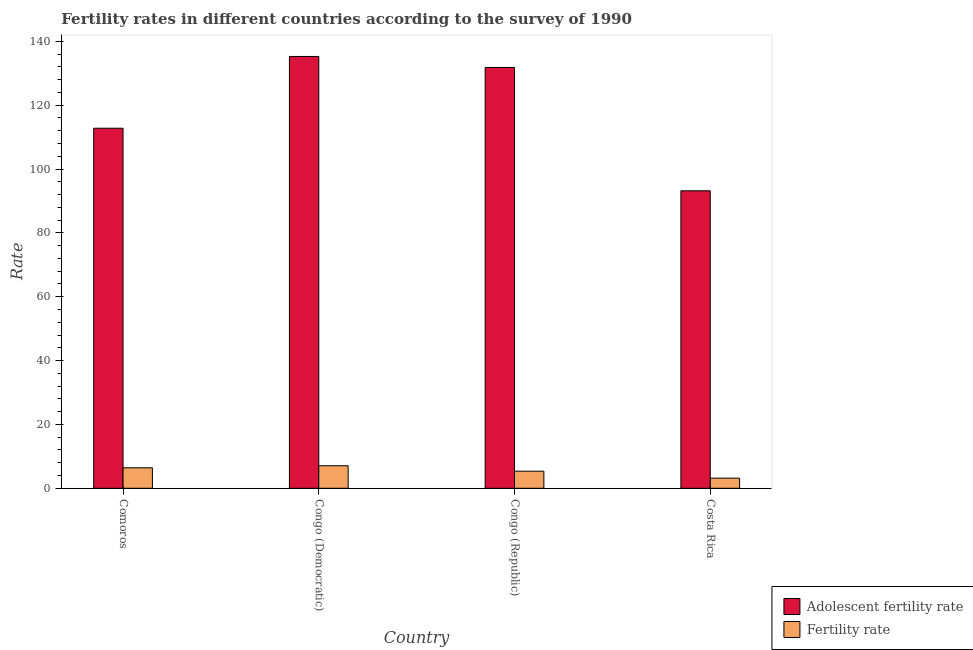Are the number of bars on each tick of the X-axis equal?
Offer a very short reply. Yes. What is the label of the 3rd group of bars from the left?
Provide a succinct answer. Congo (Republic). In how many cases, is the number of bars for a given country not equal to the number of legend labels?
Keep it short and to the point. 0. What is the adolescent fertility rate in Congo (Democratic)?
Give a very brief answer. 135.25. Across all countries, what is the maximum fertility rate?
Your answer should be very brief. 7.06. Across all countries, what is the minimum adolescent fertility rate?
Provide a succinct answer. 93.17. In which country was the fertility rate maximum?
Give a very brief answer. Congo (Democratic). What is the total fertility rate in the graph?
Ensure brevity in your answer.  21.99. What is the difference between the adolescent fertility rate in Congo (Democratic) and that in Congo (Republic)?
Keep it short and to the point. 3.44. What is the difference between the fertility rate in Congo (Republic) and the adolescent fertility rate in Comoros?
Provide a succinct answer. -107.42. What is the average adolescent fertility rate per country?
Your response must be concise. 118.25. What is the difference between the adolescent fertility rate and fertility rate in Comoros?
Keep it short and to the point. 106.36. What is the ratio of the adolescent fertility rate in Comoros to that in Congo (Democratic)?
Make the answer very short. 0.83. What is the difference between the highest and the second highest fertility rate?
Make the answer very short. 0.65. What is the difference between the highest and the lowest adolescent fertility rate?
Your answer should be very brief. 42.08. What does the 2nd bar from the left in Comoros represents?
Provide a succinct answer. Fertility rate. What does the 1st bar from the right in Comoros represents?
Make the answer very short. Fertility rate. How many bars are there?
Your answer should be compact. 8. How many countries are there in the graph?
Make the answer very short. 4. Are the values on the major ticks of Y-axis written in scientific E-notation?
Offer a very short reply. No. Does the graph contain any zero values?
Keep it short and to the point. No. Does the graph contain grids?
Offer a very short reply. No. Where does the legend appear in the graph?
Offer a very short reply. Bottom right. How are the legend labels stacked?
Provide a short and direct response. Vertical. What is the title of the graph?
Provide a succinct answer. Fertility rates in different countries according to the survey of 1990. Does "Official creditors" appear as one of the legend labels in the graph?
Provide a succinct answer. No. What is the label or title of the Y-axis?
Your answer should be compact. Rate. What is the Rate of Adolescent fertility rate in Comoros?
Provide a succinct answer. 112.77. What is the Rate of Fertility rate in Comoros?
Give a very brief answer. 6.41. What is the Rate in Adolescent fertility rate in Congo (Democratic)?
Give a very brief answer. 135.25. What is the Rate of Fertility rate in Congo (Democratic)?
Provide a short and direct response. 7.06. What is the Rate in Adolescent fertility rate in Congo (Republic)?
Keep it short and to the point. 131.81. What is the Rate of Fertility rate in Congo (Republic)?
Make the answer very short. 5.35. What is the Rate of Adolescent fertility rate in Costa Rica?
Ensure brevity in your answer.  93.17. What is the Rate of Fertility rate in Costa Rica?
Keep it short and to the point. 3.17. Across all countries, what is the maximum Rate of Adolescent fertility rate?
Offer a terse response. 135.25. Across all countries, what is the maximum Rate in Fertility rate?
Ensure brevity in your answer.  7.06. Across all countries, what is the minimum Rate of Adolescent fertility rate?
Keep it short and to the point. 93.17. Across all countries, what is the minimum Rate in Fertility rate?
Your answer should be very brief. 3.17. What is the total Rate in Adolescent fertility rate in the graph?
Offer a terse response. 473. What is the total Rate in Fertility rate in the graph?
Offer a terse response. 21.99. What is the difference between the Rate in Adolescent fertility rate in Comoros and that in Congo (Democratic)?
Provide a succinct answer. -22.48. What is the difference between the Rate in Fertility rate in Comoros and that in Congo (Democratic)?
Your answer should be compact. -0.65. What is the difference between the Rate in Adolescent fertility rate in Comoros and that in Congo (Republic)?
Ensure brevity in your answer.  -19.04. What is the difference between the Rate in Fertility rate in Comoros and that in Congo (Republic)?
Provide a succinct answer. 1.06. What is the difference between the Rate in Adolescent fertility rate in Comoros and that in Costa Rica?
Offer a terse response. 19.6. What is the difference between the Rate in Fertility rate in Comoros and that in Costa Rica?
Keep it short and to the point. 3.24. What is the difference between the Rate of Adolescent fertility rate in Congo (Democratic) and that in Congo (Republic)?
Provide a succinct answer. 3.44. What is the difference between the Rate of Fertility rate in Congo (Democratic) and that in Congo (Republic)?
Offer a very short reply. 1.71. What is the difference between the Rate of Adolescent fertility rate in Congo (Democratic) and that in Costa Rica?
Your response must be concise. 42.08. What is the difference between the Rate of Fertility rate in Congo (Democratic) and that in Costa Rica?
Keep it short and to the point. 3.89. What is the difference between the Rate of Adolescent fertility rate in Congo (Republic) and that in Costa Rica?
Offer a very short reply. 38.64. What is the difference between the Rate of Fertility rate in Congo (Republic) and that in Costa Rica?
Give a very brief answer. 2.18. What is the difference between the Rate of Adolescent fertility rate in Comoros and the Rate of Fertility rate in Congo (Democratic)?
Make the answer very short. 105.71. What is the difference between the Rate of Adolescent fertility rate in Comoros and the Rate of Fertility rate in Congo (Republic)?
Your response must be concise. 107.42. What is the difference between the Rate of Adolescent fertility rate in Comoros and the Rate of Fertility rate in Costa Rica?
Your response must be concise. 109.6. What is the difference between the Rate of Adolescent fertility rate in Congo (Democratic) and the Rate of Fertility rate in Congo (Republic)?
Give a very brief answer. 129.9. What is the difference between the Rate in Adolescent fertility rate in Congo (Democratic) and the Rate in Fertility rate in Costa Rica?
Make the answer very short. 132.08. What is the difference between the Rate in Adolescent fertility rate in Congo (Republic) and the Rate in Fertility rate in Costa Rica?
Keep it short and to the point. 128.64. What is the average Rate of Adolescent fertility rate per country?
Provide a short and direct response. 118.25. What is the average Rate in Fertility rate per country?
Give a very brief answer. 5.5. What is the difference between the Rate of Adolescent fertility rate and Rate of Fertility rate in Comoros?
Provide a short and direct response. 106.36. What is the difference between the Rate of Adolescent fertility rate and Rate of Fertility rate in Congo (Democratic)?
Your answer should be compact. 128.19. What is the difference between the Rate of Adolescent fertility rate and Rate of Fertility rate in Congo (Republic)?
Keep it short and to the point. 126.46. What is the difference between the Rate of Adolescent fertility rate and Rate of Fertility rate in Costa Rica?
Offer a terse response. 90. What is the ratio of the Rate of Adolescent fertility rate in Comoros to that in Congo (Democratic)?
Your answer should be very brief. 0.83. What is the ratio of the Rate of Fertility rate in Comoros to that in Congo (Democratic)?
Your response must be concise. 0.91. What is the ratio of the Rate in Adolescent fertility rate in Comoros to that in Congo (Republic)?
Offer a very short reply. 0.86. What is the ratio of the Rate of Fertility rate in Comoros to that in Congo (Republic)?
Offer a very short reply. 1.2. What is the ratio of the Rate in Adolescent fertility rate in Comoros to that in Costa Rica?
Your answer should be compact. 1.21. What is the ratio of the Rate of Fertility rate in Comoros to that in Costa Rica?
Offer a terse response. 2.02. What is the ratio of the Rate in Adolescent fertility rate in Congo (Democratic) to that in Congo (Republic)?
Your answer should be very brief. 1.03. What is the ratio of the Rate of Fertility rate in Congo (Democratic) to that in Congo (Republic)?
Your response must be concise. 1.32. What is the ratio of the Rate of Adolescent fertility rate in Congo (Democratic) to that in Costa Rica?
Make the answer very short. 1.45. What is the ratio of the Rate in Fertility rate in Congo (Democratic) to that in Costa Rica?
Provide a short and direct response. 2.23. What is the ratio of the Rate of Adolescent fertility rate in Congo (Republic) to that in Costa Rica?
Keep it short and to the point. 1.41. What is the ratio of the Rate of Fertility rate in Congo (Republic) to that in Costa Rica?
Ensure brevity in your answer.  1.69. What is the difference between the highest and the second highest Rate of Adolescent fertility rate?
Your response must be concise. 3.44. What is the difference between the highest and the second highest Rate of Fertility rate?
Offer a terse response. 0.65. What is the difference between the highest and the lowest Rate in Adolescent fertility rate?
Provide a short and direct response. 42.08. What is the difference between the highest and the lowest Rate of Fertility rate?
Ensure brevity in your answer.  3.89. 